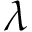Convert formula to latex. <formula><loc_0><loc_0><loc_500><loc_500>\lambda</formula> 